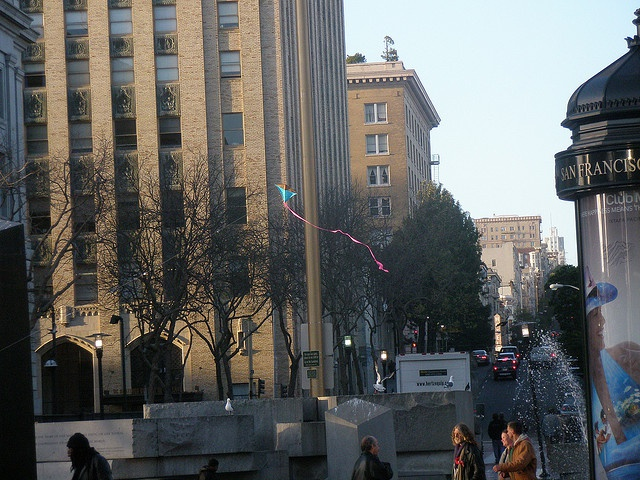Describe the objects in this image and their specific colors. I can see truck in black, gray, and blue tones, people in black, maroon, and brown tones, people in black, maroon, and gray tones, people in black, gray, and maroon tones, and people in black and gray tones in this image. 